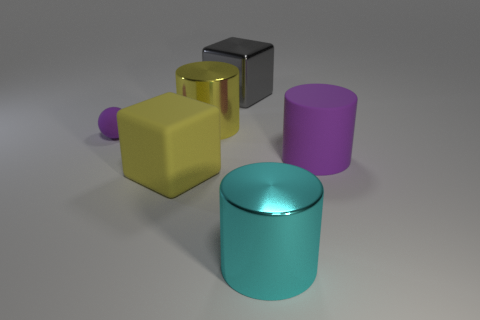There is a thing that is the same color as the matte ball; what shape is it?
Provide a short and direct response. Cylinder. What number of tiny purple objects have the same material as the gray object?
Ensure brevity in your answer.  0. What is the color of the small thing?
Give a very brief answer. Purple. What color is the rubber object that is the same size as the purple cylinder?
Your answer should be compact. Yellow. Is there a tiny rubber block of the same color as the large rubber cube?
Your response must be concise. No. There is a shiny object left of the gray cube; is it the same shape as the purple thing that is behind the big purple matte object?
Provide a short and direct response. No. There is a metal cylinder that is the same color as the large matte block; what size is it?
Your answer should be very brief. Large. How many other things are there of the same size as the yellow metallic object?
Give a very brief answer. 4. There is a large rubber cylinder; does it have the same color as the metal cylinder in front of the yellow metallic thing?
Ensure brevity in your answer.  No. Are there fewer small purple matte objects that are to the right of the large yellow shiny object than yellow metallic things on the right side of the gray shiny cube?
Give a very brief answer. No. 